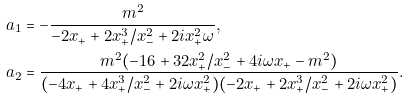<formula> <loc_0><loc_0><loc_500><loc_500>a _ { 1 } & = - \frac { m ^ { 2 } } { - 2 x _ { + } + 2 x _ { + } ^ { 3 } / x _ { - } ^ { 2 } + 2 i x _ { + } ^ { 2 } \omega } , \\ a _ { 2 } & = \frac { m ^ { 2 } ( - 1 6 + 3 2 x _ { + } ^ { 2 } / x _ { - } ^ { 2 } + 4 i \omega x _ { + } - m ^ { 2 } ) } { ( - 4 x _ { + } + 4 x _ { + } ^ { 3 } / x _ { - } ^ { 2 } + 2 i \omega x _ { + } ^ { 2 } ) ( - 2 x _ { + } + 2 x _ { + } ^ { 3 } / x _ { - } ^ { 2 } + 2 i \omega x _ { + } ^ { 2 } ) } .</formula> 